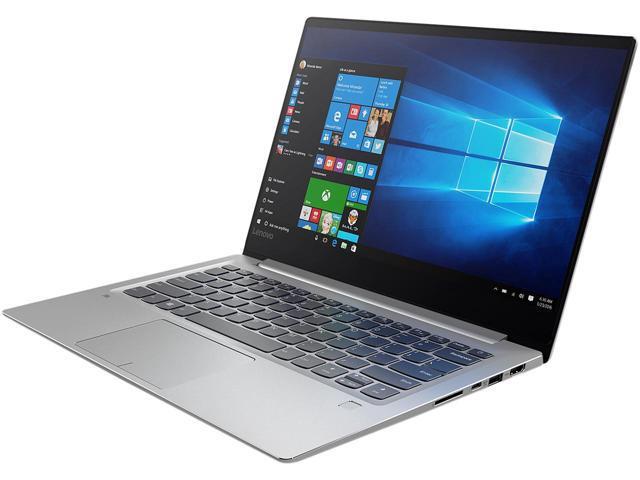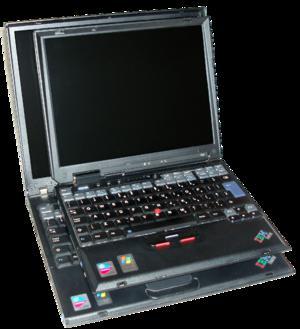The first image is the image on the left, the second image is the image on the right. Considering the images on both sides, is "The laptop on the left is displayed head-on, opened at least at a right angle, and the laptop on the right is displayed at an angle facing leftward." valid? Answer yes or no. No. The first image is the image on the left, the second image is the image on the right. Examine the images to the left and right. Is the description "The right image contains a laptop with a kickstand propping the screen up." accurate? Answer yes or no. No. 